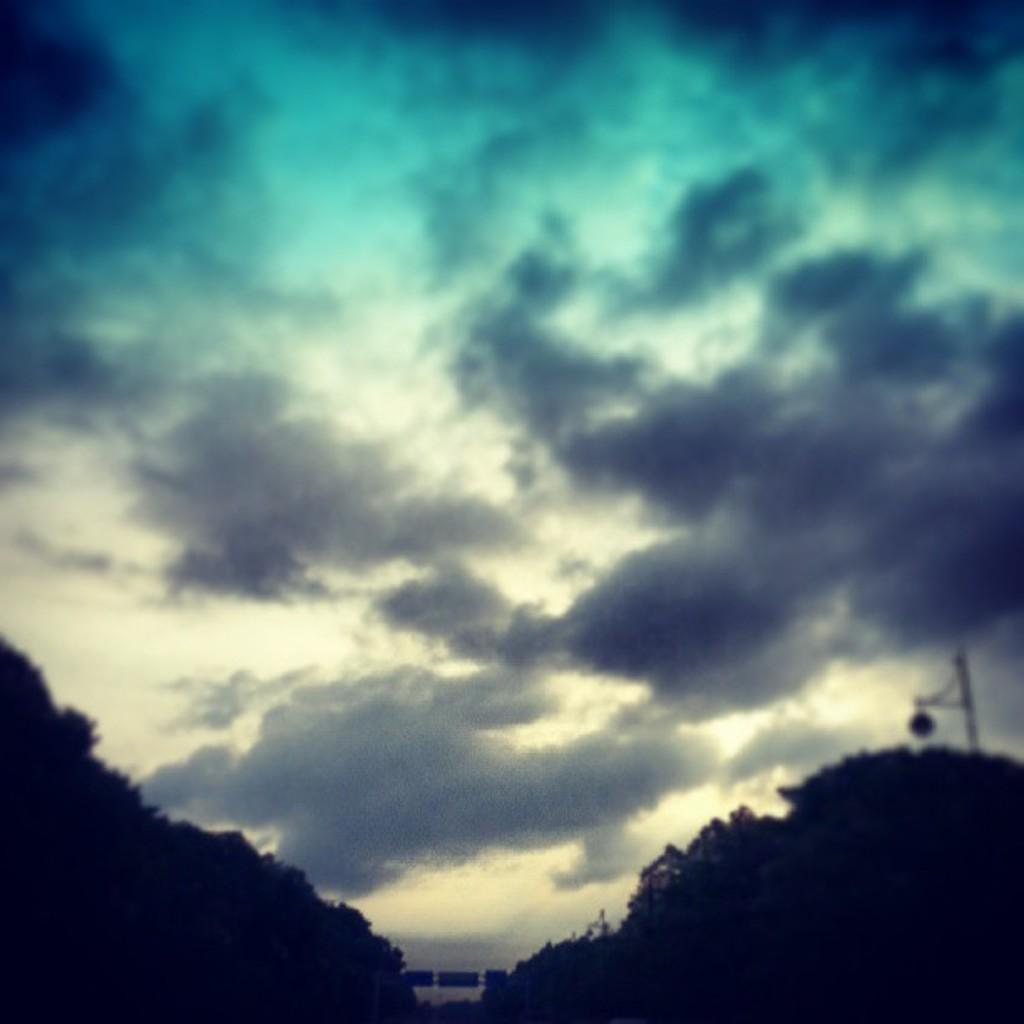What can be seen in the sky in the image? There are clouds in the sky in the image. What type of vegetation is present in the image? There are trees in the image. What object can be seen standing upright in the image? There is a pole in the image. Can you see a tiger walking on the bridge in the image? There is no tiger or bridge present in the image. What type of bean is growing on the pole in the image? There are no beans present in the image; it only features clouds, trees, and a pole. 